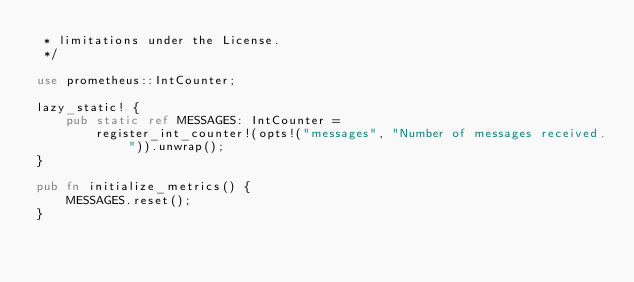Convert code to text. <code><loc_0><loc_0><loc_500><loc_500><_Rust_> * limitations under the License.
 */

use prometheus::IntCounter;

lazy_static! {
    pub static ref MESSAGES: IntCounter =
        register_int_counter!(opts!("messages", "Number of messages received.")).unwrap();
}

pub fn initialize_metrics() {
    MESSAGES.reset();
}
</code> 